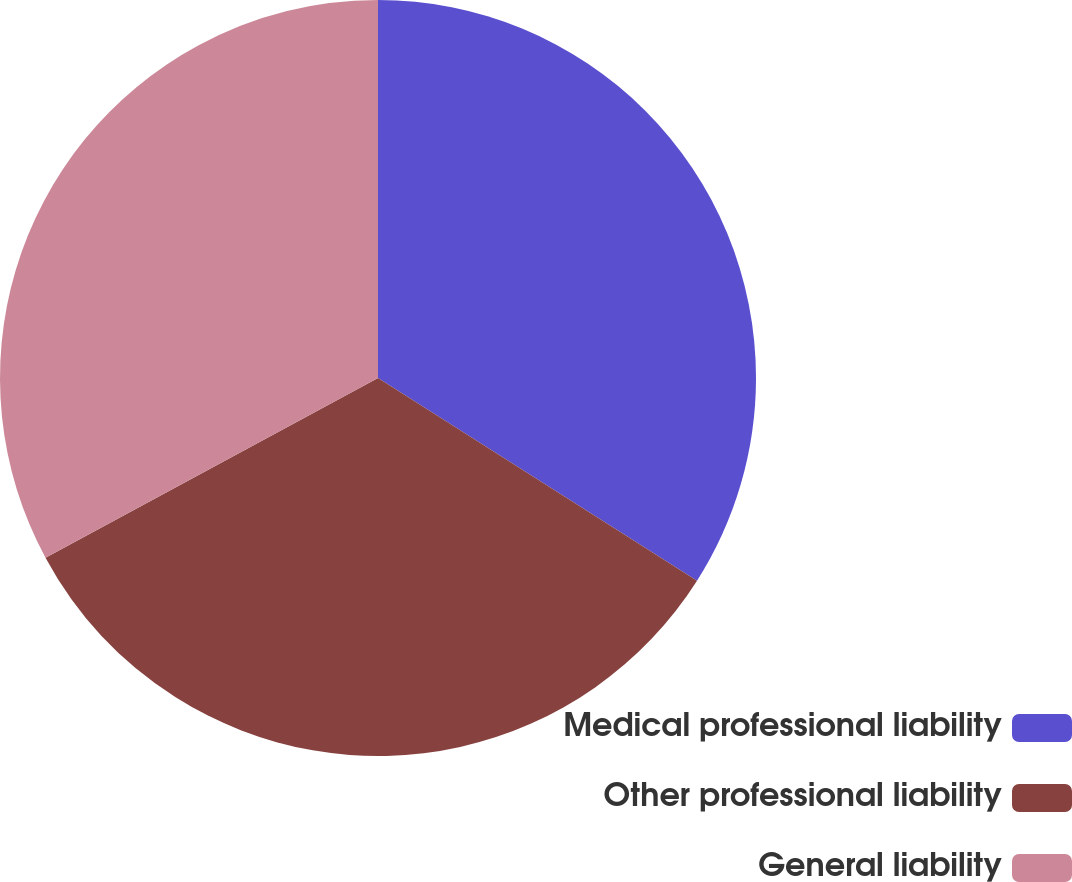Convert chart. <chart><loc_0><loc_0><loc_500><loc_500><pie_chart><fcel>Medical professional liability<fcel>Other professional liability<fcel>General liability<nl><fcel>34.01%<fcel>33.1%<fcel>32.89%<nl></chart> 